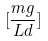<formula> <loc_0><loc_0><loc_500><loc_500>[ \frac { m g } { L d } ]</formula> 